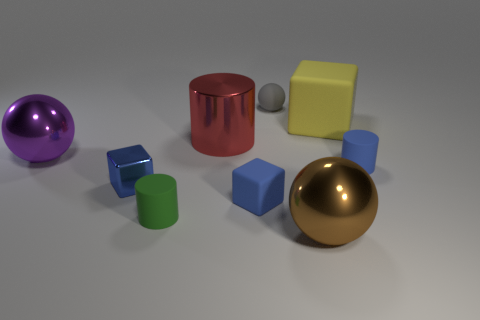There is a gray rubber thing; does it have the same shape as the brown object that is in front of the large red metal object?
Your answer should be very brief. Yes. There is a small blue block on the left side of the shiny cylinder; are there any big brown shiny objects that are on the right side of it?
Your answer should be very brief. Yes. There is a large ball on the left side of the large brown metallic thing; how many tiny green matte cylinders are in front of it?
Keep it short and to the point. 1. There is a brown thing that is the same size as the purple thing; what is its material?
Your answer should be compact. Metal. Does the large object right of the large brown metal ball have the same shape as the small blue metal thing?
Offer a very short reply. Yes. Is the number of tiny green objects in front of the large purple thing greater than the number of big shiny cylinders in front of the small green cylinder?
Make the answer very short. Yes. What number of other yellow things have the same material as the yellow object?
Provide a short and direct response. 0. Is the purple ball the same size as the green rubber thing?
Provide a short and direct response. No. What color is the shiny cylinder?
Ensure brevity in your answer.  Red. What number of objects are large cyan matte balls or red things?
Give a very brief answer. 1. 